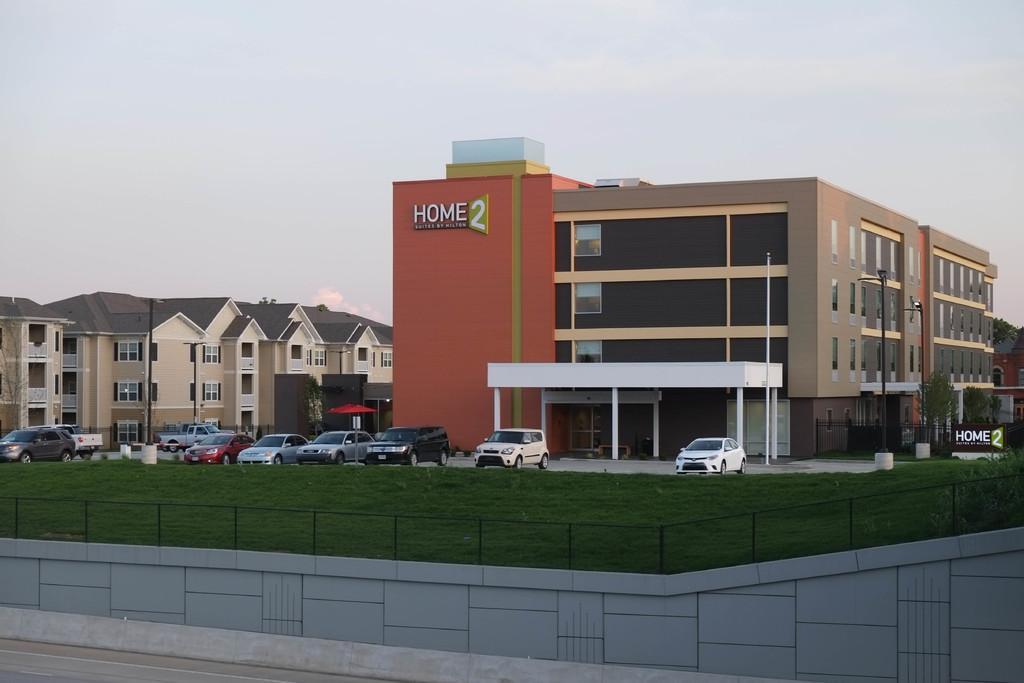Please provide a concise description of this image. In this image we can see a group of buildings. In the middle we can see some text on the building. In front of the building we can see a group of vehicles, grass and fencing on the wall. On the right side, we can see a board with text. At the top we can see the sky. 